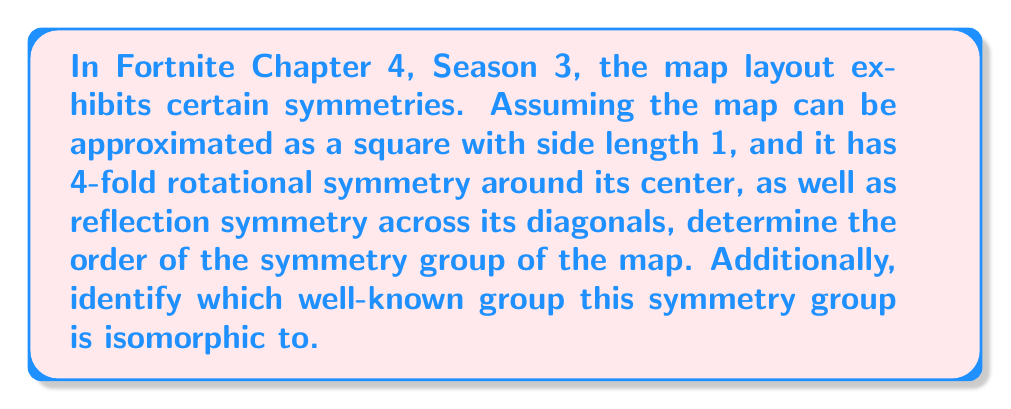Help me with this question. Let's approach this step-by-step:

1) First, let's identify the symmetries of the map:
   - 4-fold rotational symmetry (rotations by 0°, 90°, 180°, 270°)
   - Reflection across two diagonals
   - Identity transformation (doing nothing)

2) Let's count these symmetries:
   - 4 rotations (including the identity)
   - 2 reflections
   
   Total: 4 + 2 = 6 symmetries

3) The order of a group is the number of elements in the group. So, the order of this symmetry group is 6.

4) To identify which well-known group this is isomorphic to, let's consider the properties:
   - It has 6 elements
   - It includes rotations and reflections

5) This group of symmetries is isomorphic to the dihedral group $D_4$, which is the group of symmetries of a square.

6) The elements of $D_4$ can be represented as:
   $$D_4 = \{e, r, r^2, r^3, s, sr\}$$
   where $e$ is the identity, $r$ is a 90° rotation, and $s$ is a reflection.

7) We can verify that this group satisfies all the properties we observed in the Fortnite map symmetries:
   - It has order 6
   - It includes 4 rotations (including identity)
   - It includes 2 reflections

Therefore, the symmetry group of the Fortnite map is isomorphic to $D_4$.
Answer: The order of the symmetry group is 6, and it is isomorphic to the dihedral group $D_4$. 